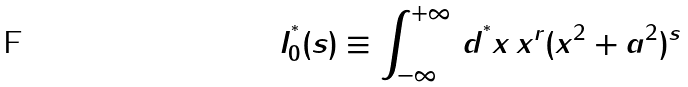<formula> <loc_0><loc_0><loc_500><loc_500>I _ { 0 } ^ { ^ { * } } ( s ) \equiv \int _ { - \infty } ^ { + \infty } \, d ^ { ^ { * } } x \, x ^ { r } ( x ^ { 2 } + a ^ { 2 } ) ^ { s }</formula> 